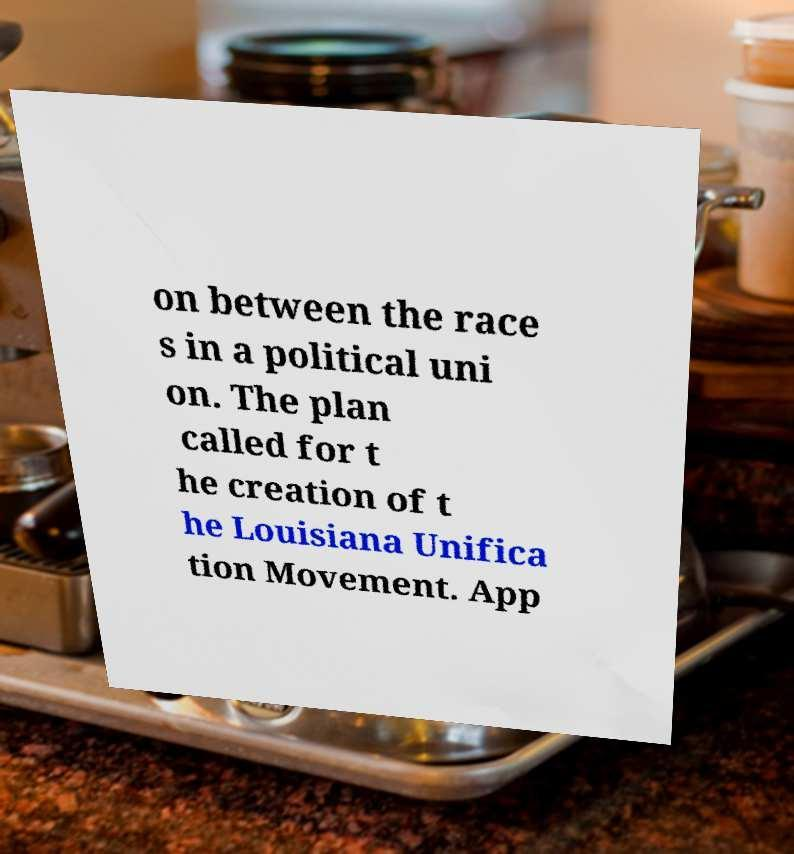What messages or text are displayed in this image? I need them in a readable, typed format. on between the race s in a political uni on. The plan called for t he creation of t he Louisiana Unifica tion Movement. App 